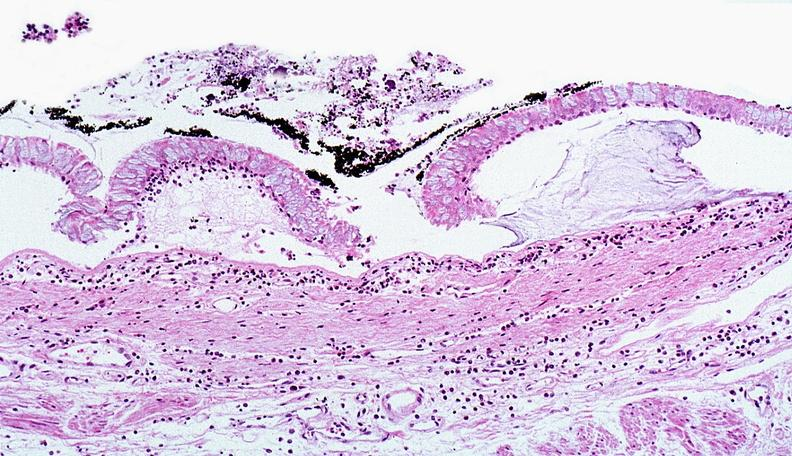where is this?
Answer the question using a single word or phrase. Skin 